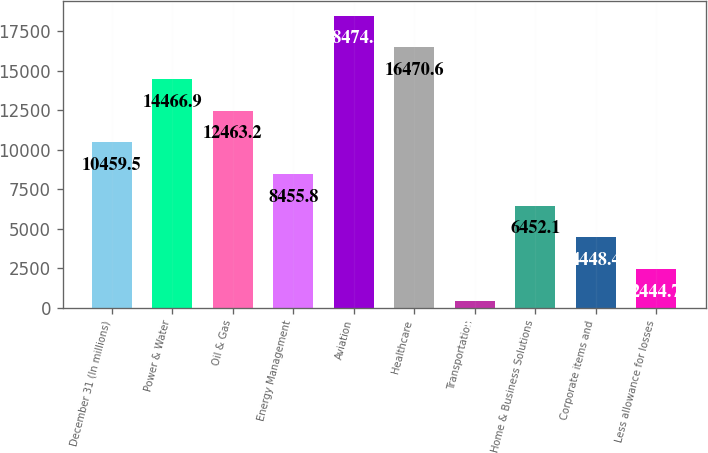<chart> <loc_0><loc_0><loc_500><loc_500><bar_chart><fcel>December 31 (In millions)<fcel>Power & Water<fcel>Oil & Gas<fcel>Energy Management<fcel>Aviation<fcel>Healthcare<fcel>Transportation<fcel>Home & Business Solutions<fcel>Corporate items and<fcel>Less allowance for losses<nl><fcel>10459.5<fcel>14466.9<fcel>12463.2<fcel>8455.8<fcel>18474.3<fcel>16470.6<fcel>441<fcel>6452.1<fcel>4448.4<fcel>2444.7<nl></chart> 